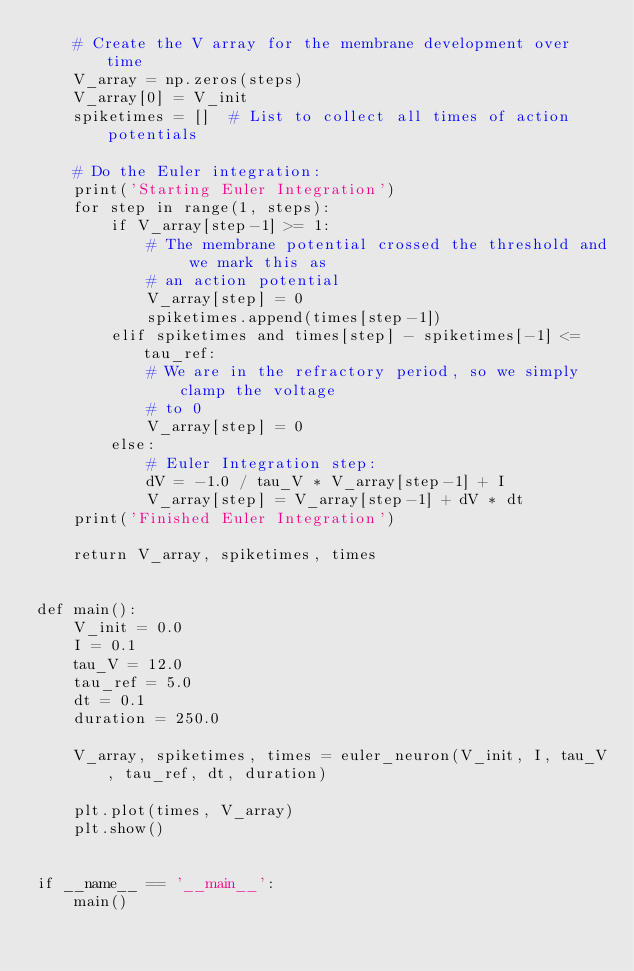<code> <loc_0><loc_0><loc_500><loc_500><_Python_>    # Create the V array for the membrane development over time
    V_array = np.zeros(steps)
    V_array[0] = V_init
    spiketimes = []  # List to collect all times of action potentials

    # Do the Euler integration:
    print('Starting Euler Integration')
    for step in range(1, steps):
        if V_array[step-1] >= 1:
            # The membrane potential crossed the threshold and we mark this as
            # an action potential
            V_array[step] = 0
            spiketimes.append(times[step-1])
        elif spiketimes and times[step] - spiketimes[-1] <= tau_ref:
            # We are in the refractory period, so we simply clamp the voltage
            # to 0
            V_array[step] = 0
        else:
            # Euler Integration step:
            dV = -1.0 / tau_V * V_array[step-1] + I
            V_array[step] = V_array[step-1] + dV * dt
    print('Finished Euler Integration')

    return V_array, spiketimes, times


def main():
    V_init = 0.0
    I = 0.1
    tau_V = 12.0
    tau_ref = 5.0
    dt = 0.1
    duration = 250.0

    V_array, spiketimes, times = euler_neuron(V_init, I, tau_V, tau_ref, dt, duration)

    plt.plot(times, V_array)
    plt.show()


if __name__ == '__main__':
    main()</code> 